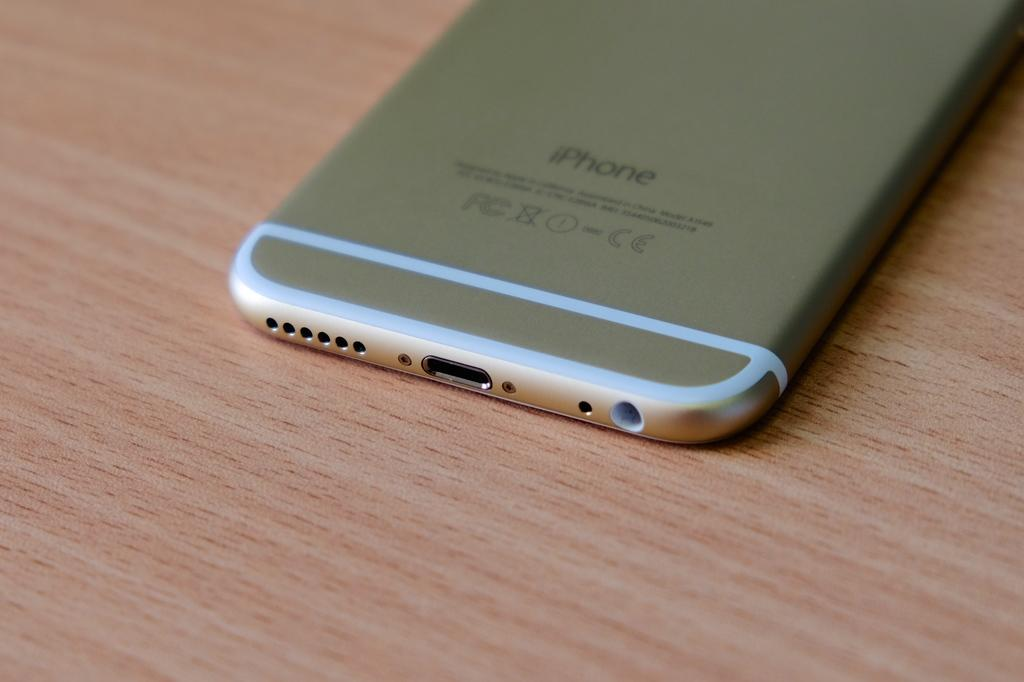<image>
Present a compact description of the photo's key features. a gold iphone sits on an empty wooden desk 